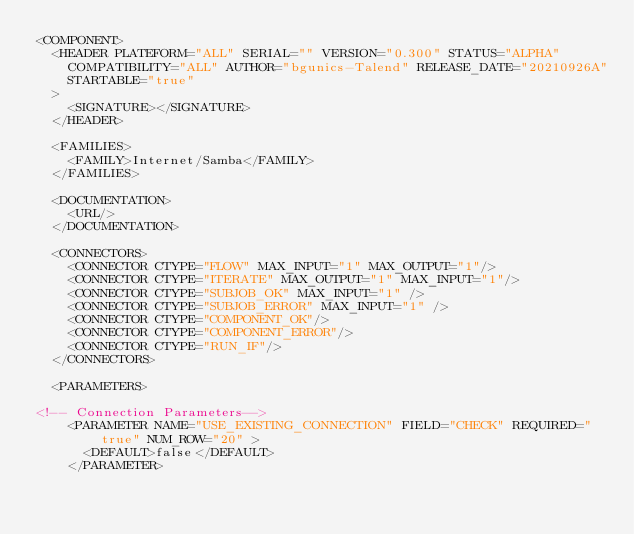<code> <loc_0><loc_0><loc_500><loc_500><_XML_><COMPONENT>
  <HEADER PLATEFORM="ALL" SERIAL="" VERSION="0.300" STATUS="ALPHA"
    COMPATIBILITY="ALL" AUTHOR="bgunics-Talend" RELEASE_DATE="20210926A"
    STARTABLE="true"
  >
    <SIGNATURE></SIGNATURE>
  </HEADER>

  <FAMILIES>
    <FAMILY>Internet/Samba</FAMILY>
  </FAMILIES>

  <DOCUMENTATION>
    <URL/>
  </DOCUMENTATION>

  <CONNECTORS>
    <CONNECTOR CTYPE="FLOW" MAX_INPUT="1" MAX_OUTPUT="1"/>
    <CONNECTOR CTYPE="ITERATE" MAX_OUTPUT="1" MAX_INPUT="1"/>
    <CONNECTOR CTYPE="SUBJOB_OK" MAX_INPUT="1" />
    <CONNECTOR CTYPE="SUBJOB_ERROR" MAX_INPUT="1" />
    <CONNECTOR CTYPE="COMPONENT_OK"/>
    <CONNECTOR CTYPE="COMPONENT_ERROR"/>
    <CONNECTOR CTYPE="RUN_IF"/>
  </CONNECTORS>

  <PARAMETERS>
  
<!-- Connection Parameters-->  
    <PARAMETER NAME="USE_EXISTING_CONNECTION" FIELD="CHECK" REQUIRED="true" NUM_ROW="20" >
      <DEFAULT>false</DEFAULT>
    </PARAMETER></code> 